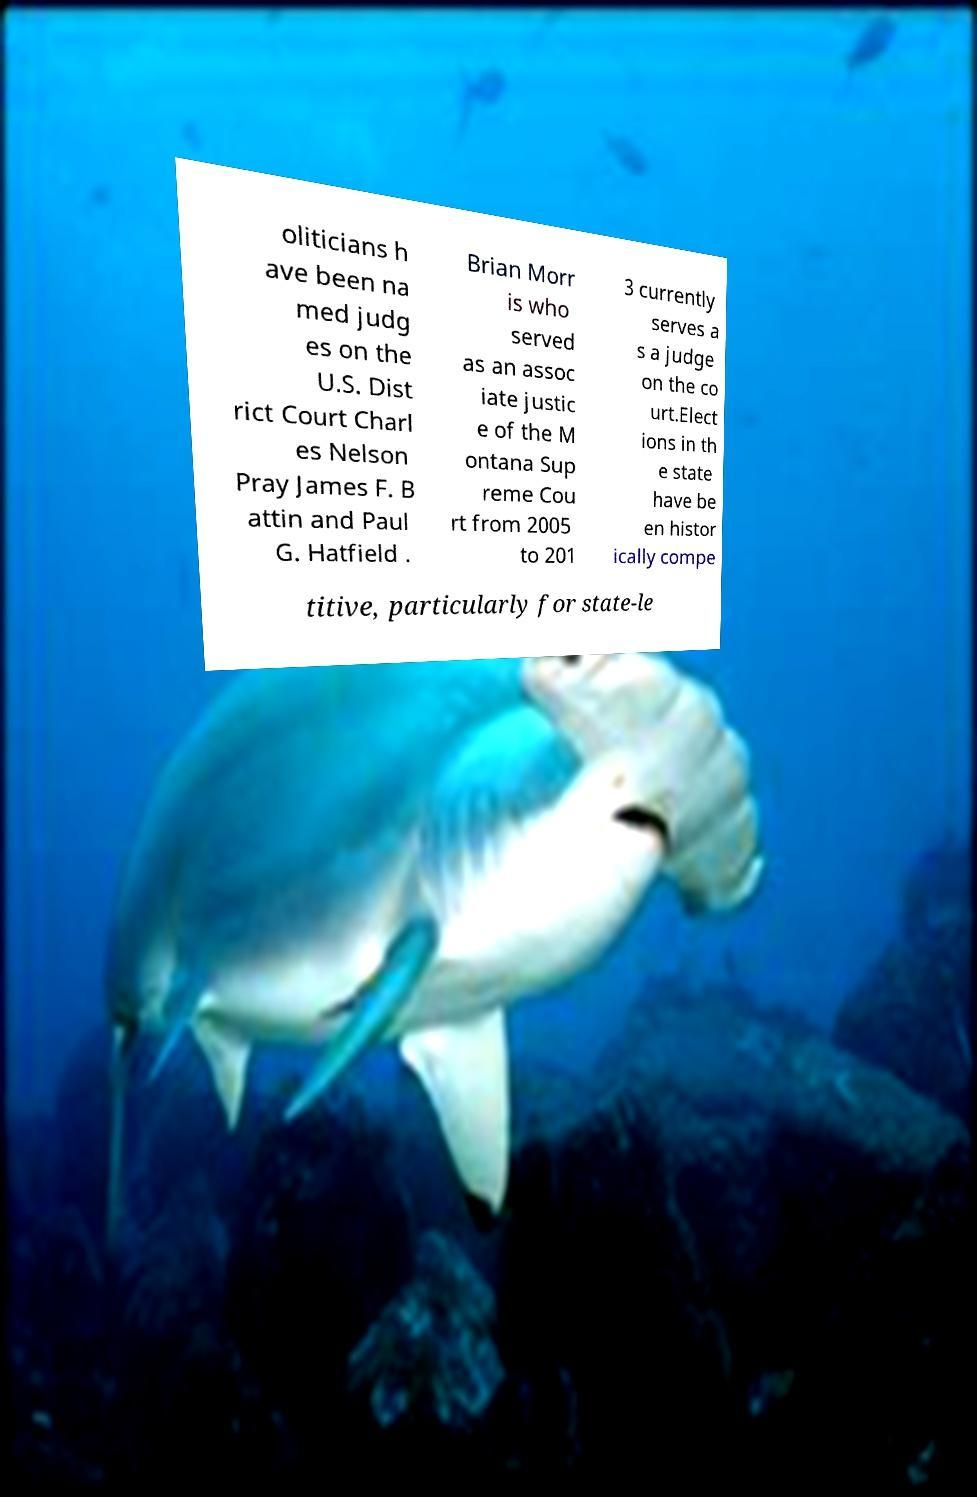There's text embedded in this image that I need extracted. Can you transcribe it verbatim? oliticians h ave been na med judg es on the U.S. Dist rict Court Charl es Nelson Pray James F. B attin and Paul G. Hatfield . Brian Morr is who served as an assoc iate justic e of the M ontana Sup reme Cou rt from 2005 to 201 3 currently serves a s a judge on the co urt.Elect ions in th e state have be en histor ically compe titive, particularly for state-le 